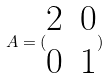<formula> <loc_0><loc_0><loc_500><loc_500>A = ( \begin{matrix} 2 & 0 \\ 0 & 1 \end{matrix} )</formula> 